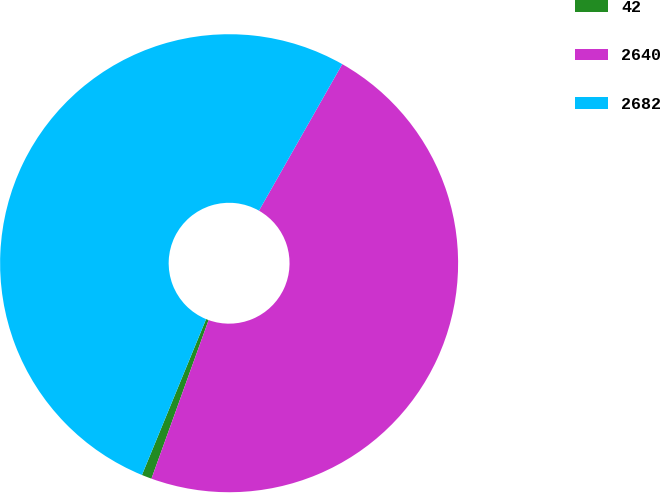<chart> <loc_0><loc_0><loc_500><loc_500><pie_chart><fcel>42<fcel>2640<fcel>2682<nl><fcel>0.71%<fcel>47.28%<fcel>52.01%<nl></chart> 